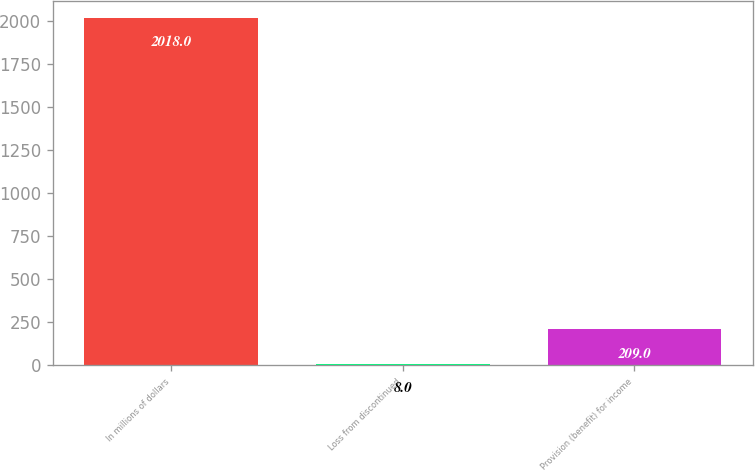Convert chart to OTSL. <chart><loc_0><loc_0><loc_500><loc_500><bar_chart><fcel>In millions of dollars<fcel>Loss from discontinued<fcel>Provision (benefit) for income<nl><fcel>2018<fcel>8<fcel>209<nl></chart> 